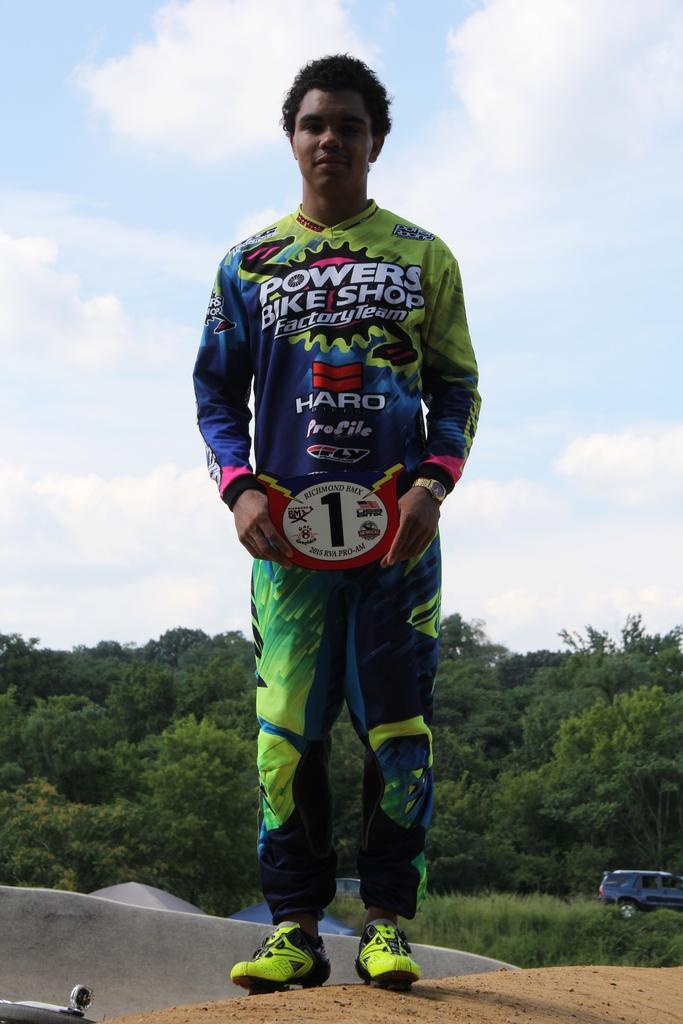<image>
Render a clear and concise summary of the photo. A young man with a number one and sponsored by Bowers bike shop before a race. 